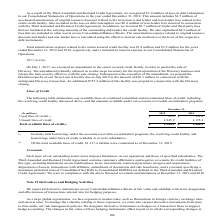According to Sealed Air Corporation's financial document, How much was commited as of December 31, 2019 of total available lines of credit? According to the financial document, $1,137.4 million. The relevant text states: "(2) Of the total available lines of credit, $1,137.4 million were committed as of December 31, 2019...." Also, What does the table show? summarizes our available lines of credit and committed and uncommitted lines of credit, including the revolving credit facility discussed above, and the amounts available under our accounts receivable securitization programs.. The document states: "The following table summarizes our available lines of credit and committed and uncommitted lines of credit, including the revolving credit facility di..." Also, What years are included in the table? The document shows two values: 2019 and 2018. From the document: "(In millions) 2019 2018 (In millions) 2019 2018..." Also, can you calculate: How much money has not been committed as of December 31, 2019 for total available lines of credit? Based on the calculation: 1,344.1-1,137.4, the result is 206.7 (in millions). This is based on the information: "Total available lines of credit (2) $ 1,344.1 $ 1,368.1 (2) Of the total available lines of credit, $1,137.4 million were committed as of December 31, 2019...." The key data points involved are: 1,137.4, 1,344.1. Also, can you calculate: What is the percentage of used lines of credit to Total available lines of credit as of December 31, 2019? Based on the calculation: 98.9/1,344.1, the result is 7.36 (percentage). This is based on the information: "Used lines of credit (1) $ 98.9 $ 232.8 Total available lines of credit (2) $ 1,344.1 $ 1,368.1..." The key data points involved are: 1,344.1, 98.9. Also, can you calculate: What is the difference between the Unused lines of credit for 2019 and 2018? Based on the calculation: 1,245.2-1,135.3, the result is 109.9 (in millions). This is based on the information: "Unused lines of credit 1,245.2 1,135.3 Unused lines of credit 1,245.2 1,135.3..." The key data points involved are: 1,135.3, 1,245.2. 